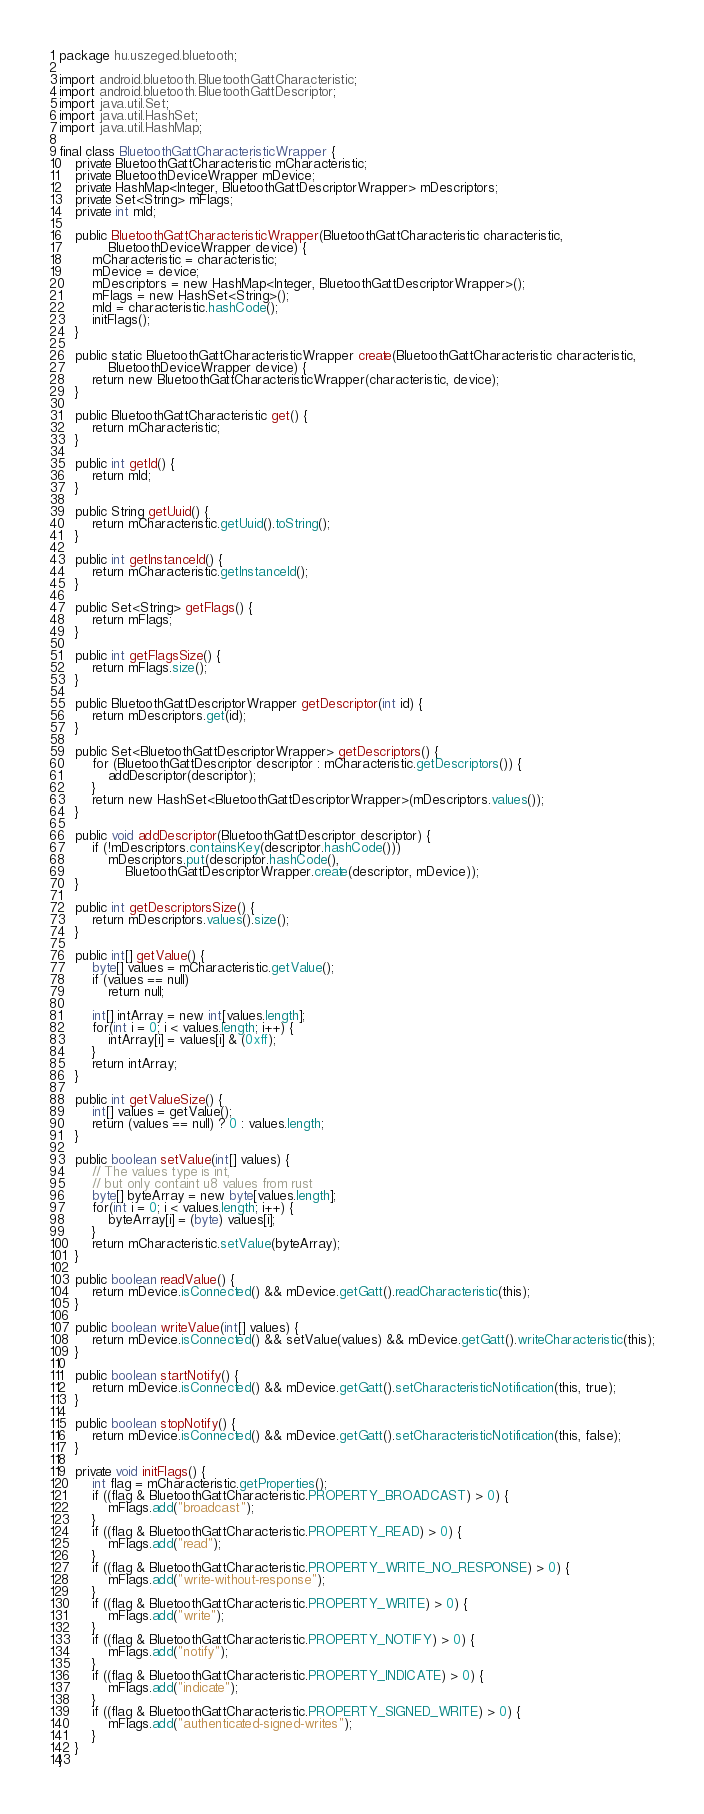<code> <loc_0><loc_0><loc_500><loc_500><_Java_>package hu.uszeged.bluetooth;

import android.bluetooth.BluetoothGattCharacteristic;
import android.bluetooth.BluetoothGattDescriptor;
import java.util.Set;
import java.util.HashSet;
import java.util.HashMap;

final class BluetoothGattCharacteristicWrapper {
    private BluetoothGattCharacteristic mCharacteristic;
    private BluetoothDeviceWrapper mDevice;
    private HashMap<Integer, BluetoothGattDescriptorWrapper> mDescriptors;
    private Set<String> mFlags;
    private int mId;

    public BluetoothGattCharacteristicWrapper(BluetoothGattCharacteristic characteristic,
            BluetoothDeviceWrapper device) {
        mCharacteristic = characteristic;
        mDevice = device;
        mDescriptors = new HashMap<Integer, BluetoothGattDescriptorWrapper>();
        mFlags = new HashSet<String>();
        mId = characteristic.hashCode();
        initFlags();
    }

    public static BluetoothGattCharacteristicWrapper create(BluetoothGattCharacteristic characteristic,
            BluetoothDeviceWrapper device) {
        return new BluetoothGattCharacteristicWrapper(characteristic, device);
    }

    public BluetoothGattCharacteristic get() {
        return mCharacteristic;
    }

    public int getId() {
        return mId;
    }

    public String getUuid() {
        return mCharacteristic.getUuid().toString();
    }

    public int getInstanceId() {
        return mCharacteristic.getInstanceId();
    }

    public Set<String> getFlags() {
        return mFlags;
    }

    public int getFlagsSize() {
        return mFlags.size();
    }

    public BluetoothGattDescriptorWrapper getDescriptor(int id) {
        return mDescriptors.get(id);
    }

    public Set<BluetoothGattDescriptorWrapper> getDescriptors() {
        for (BluetoothGattDescriptor descriptor : mCharacteristic.getDescriptors()) {
            addDescriptor(descriptor);
        }
        return new HashSet<BluetoothGattDescriptorWrapper>(mDescriptors.values());
    }

    public void addDescriptor(BluetoothGattDescriptor descriptor) {
        if (!mDescriptors.containsKey(descriptor.hashCode()))
            mDescriptors.put(descriptor.hashCode(),
                BluetoothGattDescriptorWrapper.create(descriptor, mDevice));
    }

    public int getDescriptorsSize() {
        return mDescriptors.values().size();
    }

    public int[] getValue() {
        byte[] values = mCharacteristic.getValue();
        if (values == null)
            return null;

        int[] intArray = new int[values.length];
        for(int i = 0; i < values.length; i++) {
            intArray[i] = values[i] & (0xff);
        }
        return intArray;
    }

    public int getValueSize() {
        int[] values = getValue();
        return (values == null) ? 0 : values.length;
    }

    public boolean setValue(int[] values) {
        // The values type is int,
        // but only containt u8 values from rust
        byte[] byteArray = new byte[values.length];
        for(int i = 0; i < values.length; i++) {
            byteArray[i] = (byte) values[i];
        }
        return mCharacteristic.setValue(byteArray);
    }

    public boolean readValue() {
        return mDevice.isConnected() && mDevice.getGatt().readCharacteristic(this);
    }

    public boolean writeValue(int[] values) {
        return mDevice.isConnected() && setValue(values) && mDevice.getGatt().writeCharacteristic(this);
    }

    public boolean startNotify() {
        return mDevice.isConnected() && mDevice.getGatt().setCharacteristicNotification(this, true);
    }

    public boolean stopNotify() {
        return mDevice.isConnected() && mDevice.getGatt().setCharacteristicNotification(this, false);
    }

    private void initFlags() {
        int flag = mCharacteristic.getProperties();
        if ((flag & BluetoothGattCharacteristic.PROPERTY_BROADCAST) > 0) {
            mFlags.add("broadcast");
        }
        if ((flag & BluetoothGattCharacteristic.PROPERTY_READ) > 0) {
            mFlags.add("read");
        }
        if ((flag & BluetoothGattCharacteristic.PROPERTY_WRITE_NO_RESPONSE) > 0) {
            mFlags.add("write-without-response");
        }
        if ((flag & BluetoothGattCharacteristic.PROPERTY_WRITE) > 0) {
            mFlags.add("write");
        }
        if ((flag & BluetoothGattCharacteristic.PROPERTY_NOTIFY) > 0) {
            mFlags.add("notify");
        }
        if ((flag & BluetoothGattCharacteristic.PROPERTY_INDICATE) > 0) {
            mFlags.add("indicate");
        }
        if ((flag & BluetoothGattCharacteristic.PROPERTY_SIGNED_WRITE) > 0) {
            mFlags.add("authenticated-signed-writes");
        }
    }
}
</code> 